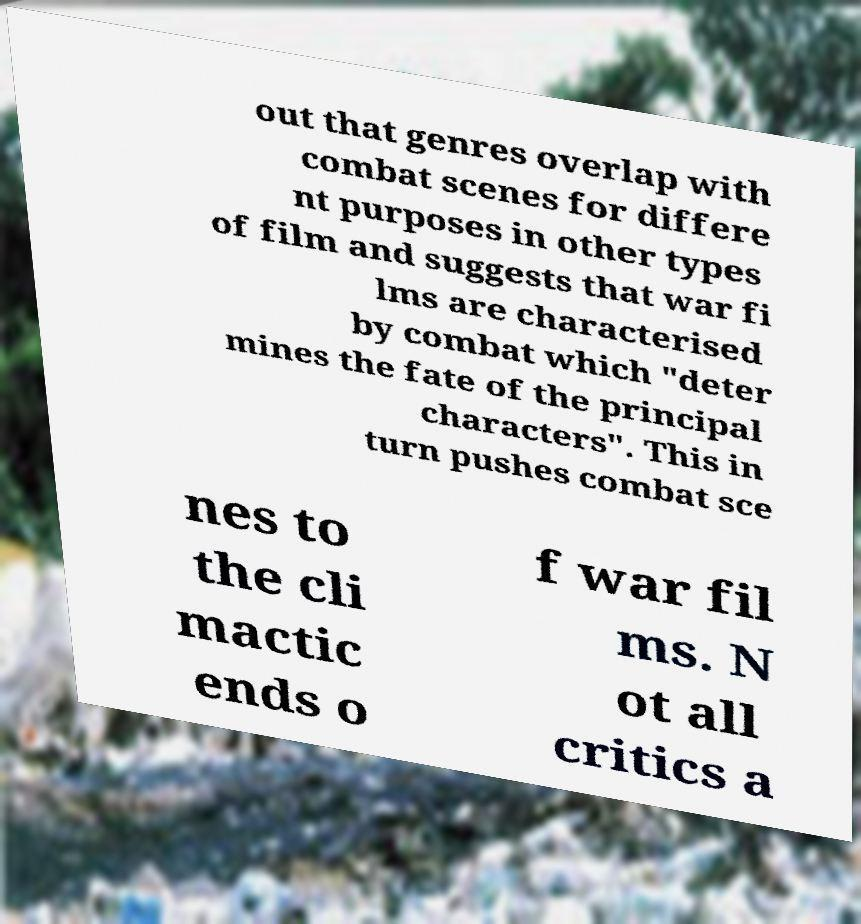Can you read and provide the text displayed in the image?This photo seems to have some interesting text. Can you extract and type it out for me? out that genres overlap with combat scenes for differe nt purposes in other types of film and suggests that war fi lms are characterised by combat which "deter mines the fate of the principal characters". This in turn pushes combat sce nes to the cli mactic ends o f war fil ms. N ot all critics a 